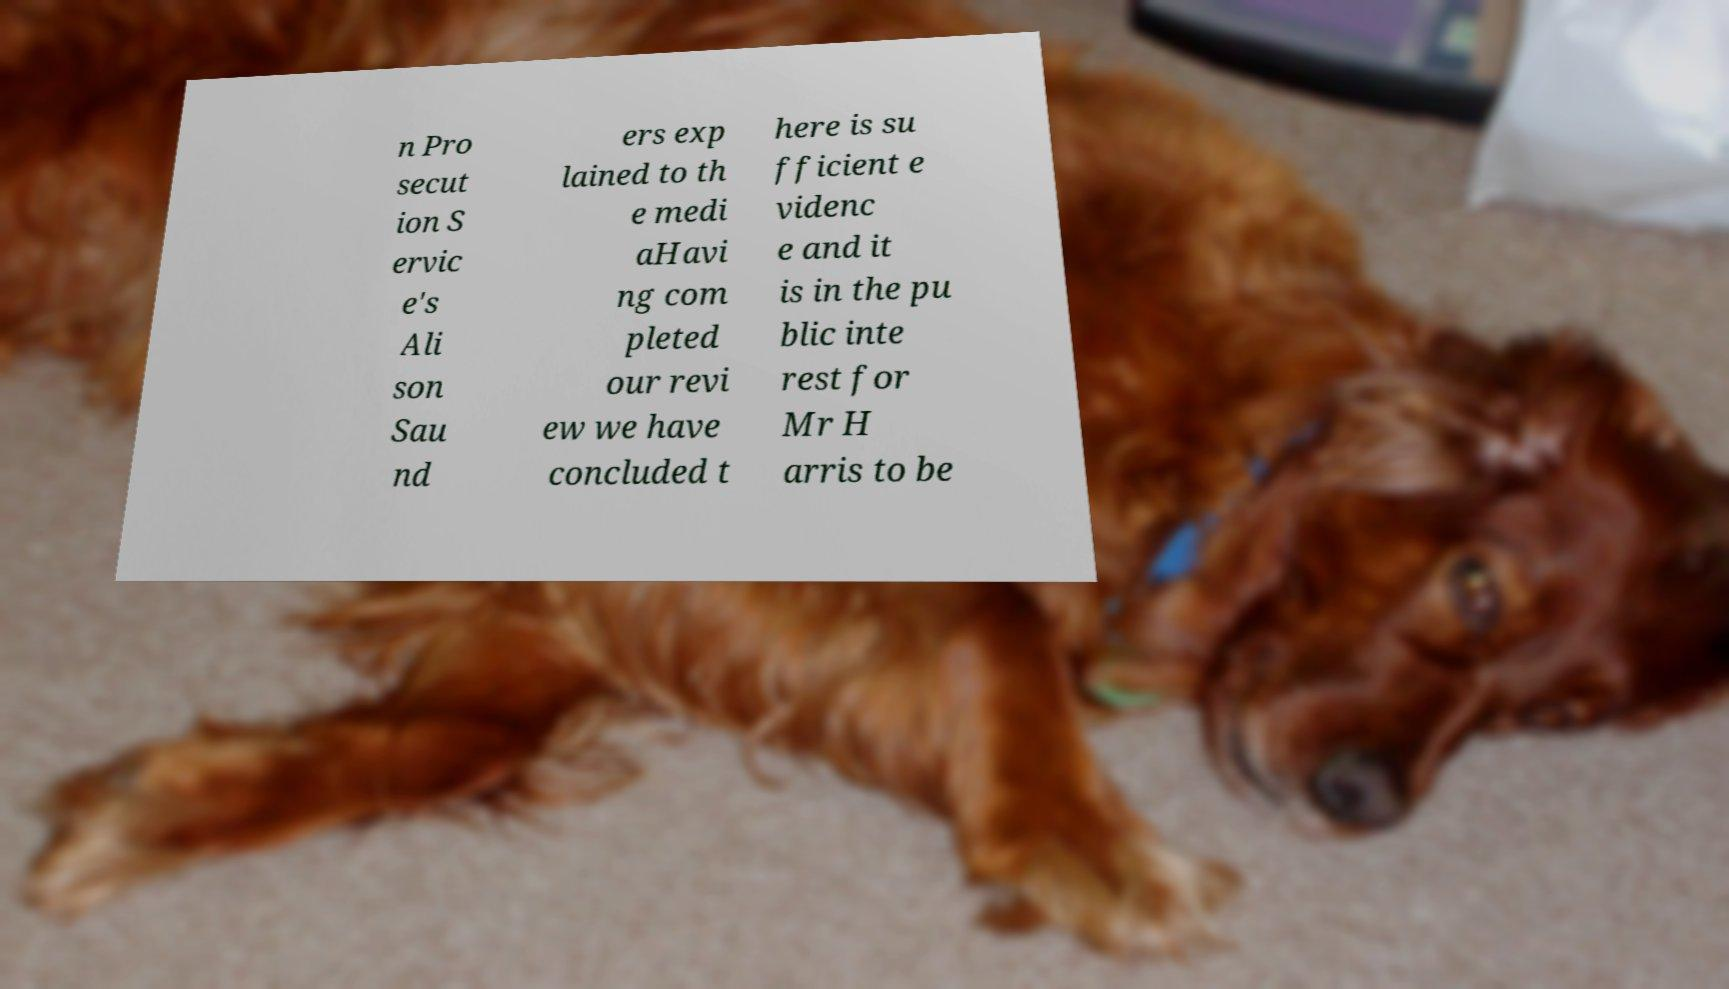There's text embedded in this image that I need extracted. Can you transcribe it verbatim? n Pro secut ion S ervic e's Ali son Sau nd ers exp lained to th e medi aHavi ng com pleted our revi ew we have concluded t here is su fficient e videnc e and it is in the pu blic inte rest for Mr H arris to be 